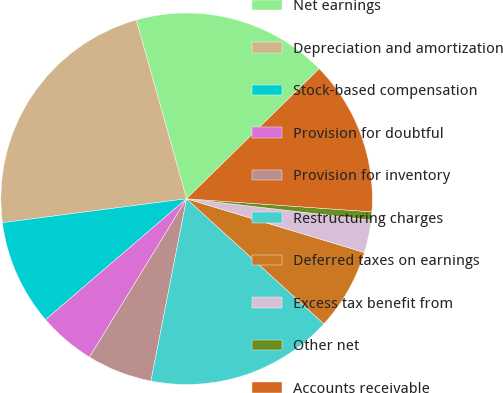<chart> <loc_0><loc_0><loc_500><loc_500><pie_chart><fcel>Net earnings<fcel>Depreciation and amortization<fcel>Stock-based compensation<fcel>Provision for doubtful<fcel>Provision for inventory<fcel>Restructuring charges<fcel>Deferred taxes on earnings<fcel>Excess tax benefit from<fcel>Other net<fcel>Accounts receivable<nl><fcel>17.02%<fcel>22.69%<fcel>9.22%<fcel>4.97%<fcel>5.68%<fcel>16.31%<fcel>7.09%<fcel>2.84%<fcel>0.71%<fcel>13.47%<nl></chart> 